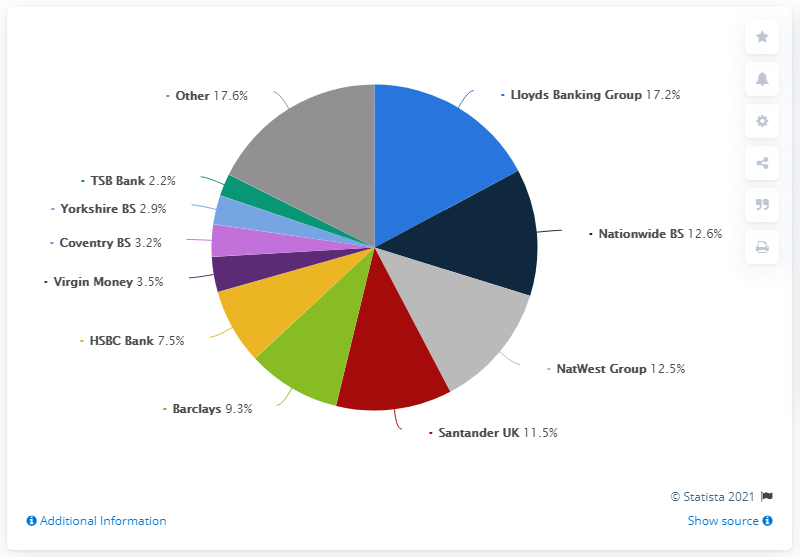Identify some key points in this picture. Lloyds Banking Group had the largest market share of gross mortgage lending in The percentage of Barclays is 9.3. The percentage difference between other and Barclays is 8.3%. 